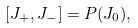Convert formula to latex. <formula><loc_0><loc_0><loc_500><loc_500>[ J _ { + } , J _ { - } ] = P ( J _ { 0 } ) ,</formula> 